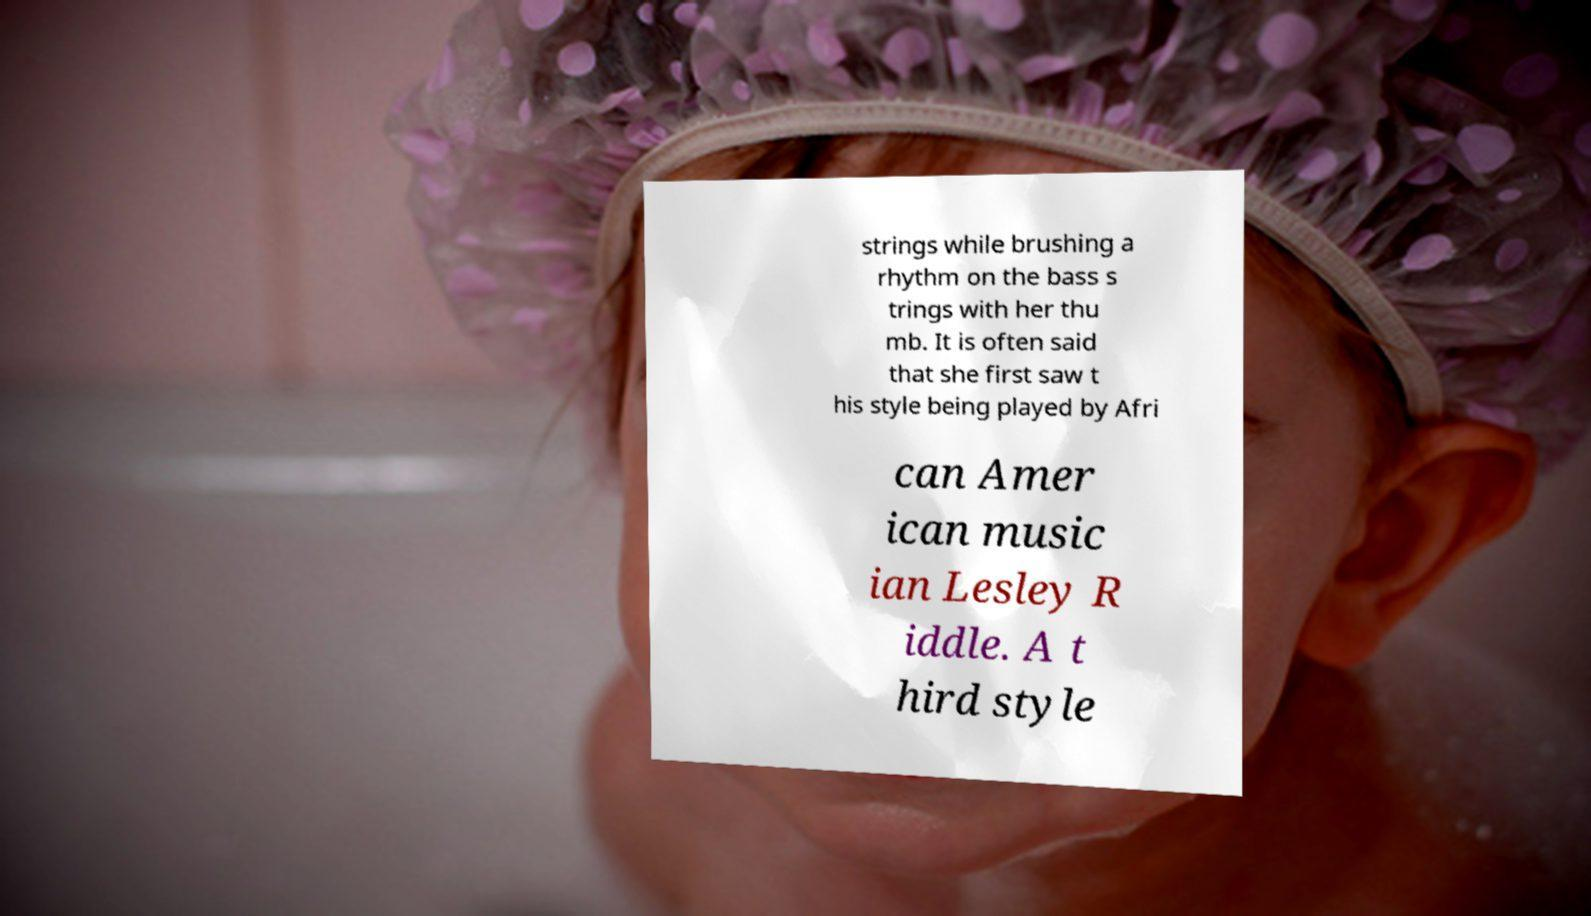I need the written content from this picture converted into text. Can you do that? strings while brushing a rhythm on the bass s trings with her thu mb. It is often said that she first saw t his style being played by Afri can Amer ican music ian Lesley R iddle. A t hird style 